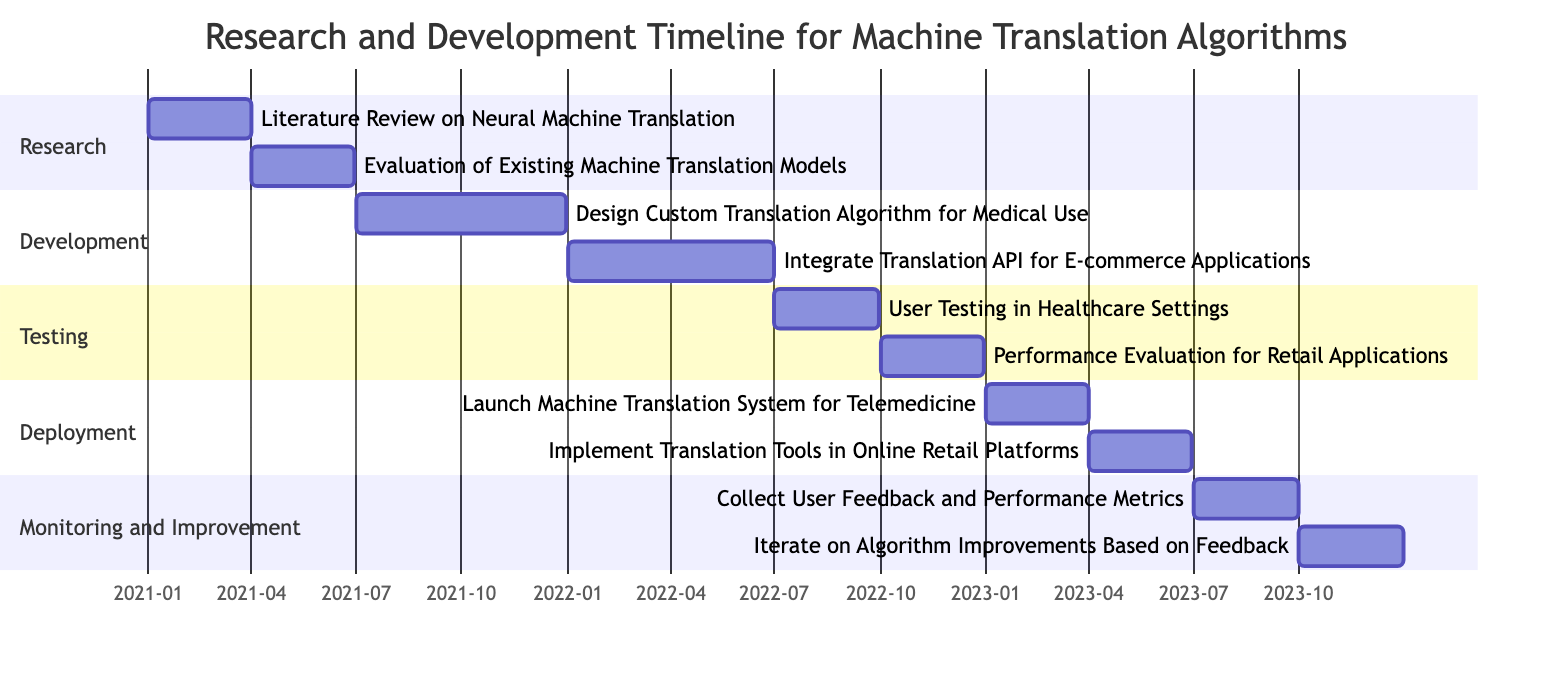What is the duration of the "Design Custom Translation Algorithm for Medical Use" task? The task "Design Custom Translation Algorithm for Medical Use" starts on July 1, 2021, and ends on December 31, 2021. Calculating the duration involves counting the days from the start date to the end date, which is approximately 184 days.
Answer: 184 days Which phase includes the task "User Testing in Healthcare Settings"? The task "User Testing in Healthcare Settings" is listed under the "Testing" phase. Each phase has its tasks categorized, and this specific task falls under the Testing section of the Gantt chart.
Answer: Testing How many tasks are scheduled in the "Deployment" phase? The "Deployment" phase contains two tasks: "Launch Machine Translation System for Telemedicine" and "Implement Translation Tools in Online Retail Platforms." Counting these tasks gives a total of two for this phase.
Answer: 2 What is the start date of the "Iterate on Algorithm Improvements Based on Feedback" task? The task "Iterate on Algorithm Improvements Based on Feedback" starts on October 1, 2023. This information is present in the Gantt chart under the "Monitoring and Improvement" section.
Answer: October 1, 2023 Which task occurs immediately after the "Collect User Feedback and Performance Metrics" task? The task that occurs immediately after "Collect User Feedback and Performance Metrics," which ends on September 30, 2023, is "Iterate on Algorithm Improvements Based on Feedback," starting on October 1, 2023. The timing indicates this sequential relationship.
Answer: Iterate on Algorithm Improvements Based on Feedback 